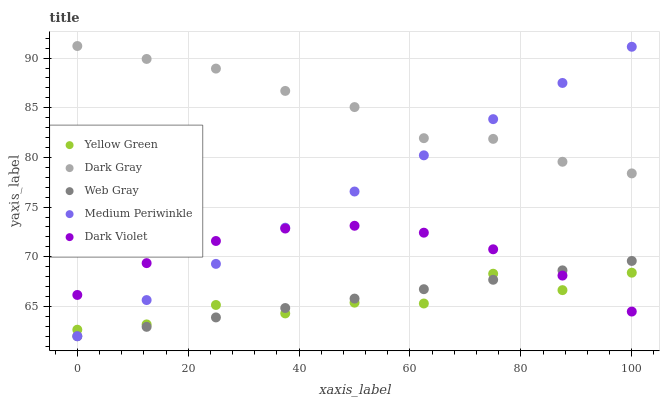Does Yellow Green have the minimum area under the curve?
Answer yes or no. Yes. Does Dark Gray have the maximum area under the curve?
Answer yes or no. Yes. Does Web Gray have the minimum area under the curve?
Answer yes or no. No. Does Web Gray have the maximum area under the curve?
Answer yes or no. No. Is Web Gray the smoothest?
Answer yes or no. Yes. Is Yellow Green the roughest?
Answer yes or no. Yes. Is Medium Periwinkle the smoothest?
Answer yes or no. No. Is Medium Periwinkle the roughest?
Answer yes or no. No. Does Web Gray have the lowest value?
Answer yes or no. Yes. Does Yellow Green have the lowest value?
Answer yes or no. No. Does Dark Gray have the highest value?
Answer yes or no. Yes. Does Web Gray have the highest value?
Answer yes or no. No. Is Yellow Green less than Dark Gray?
Answer yes or no. Yes. Is Dark Gray greater than Yellow Green?
Answer yes or no. Yes. Does Medium Periwinkle intersect Web Gray?
Answer yes or no. Yes. Is Medium Periwinkle less than Web Gray?
Answer yes or no. No. Is Medium Periwinkle greater than Web Gray?
Answer yes or no. No. Does Yellow Green intersect Dark Gray?
Answer yes or no. No. 